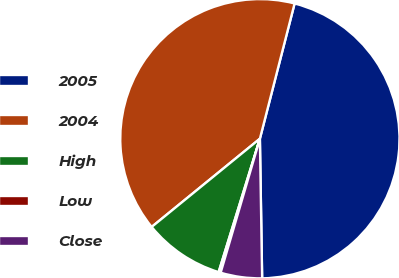<chart> <loc_0><loc_0><loc_500><loc_500><pie_chart><fcel>2005<fcel>2004<fcel>High<fcel>Low<fcel>Close<nl><fcel>45.74%<fcel>39.88%<fcel>9.34%<fcel>0.24%<fcel>4.79%<nl></chart> 